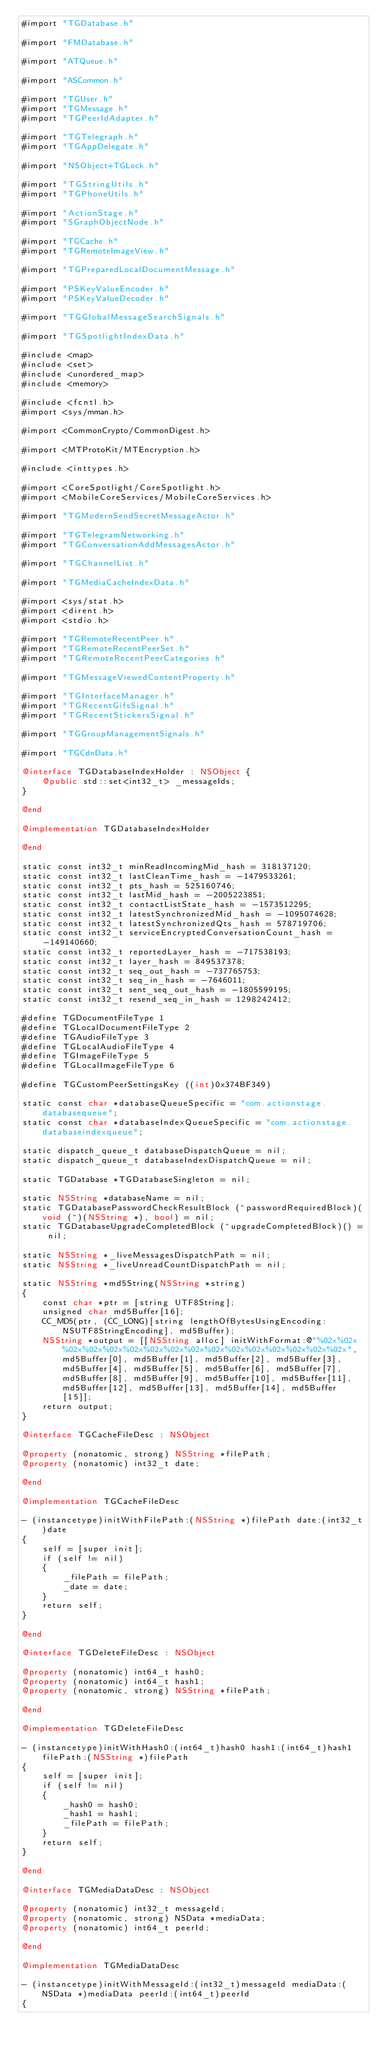<code> <loc_0><loc_0><loc_500><loc_500><_ObjectiveC_>#import "TGDatabase.h"

#import "FMDatabase.h"

#import "ATQueue.h"

#import "ASCommon.h"

#import "TGUser.h"
#import "TGMessage.h"
#import "TGPeerIdAdapter.h"

#import "TGTelegraph.h"
#import "TGAppDelegate.h"

#import "NSObject+TGLock.h"

#import "TGStringUtils.h"
#import "TGPhoneUtils.h"

#import "ActionStage.h"
#import "SGraphObjectNode.h"

#import "TGCache.h"
#import "TGRemoteImageView.h"

#import "TGPreparedLocalDocumentMessage.h"

#import "PSKeyValueEncoder.h"
#import "PSKeyValueDecoder.h"

#import "TGGlobalMessageSearchSignals.h"

#import "TGSpotlightIndexData.h"

#include <map>
#include <set>
#include <unordered_map>
#include <memory>

#include <fcntl.h>
#import <sys/mman.h>

#import <CommonCrypto/CommonDigest.h>

#import <MTProtoKit/MTEncryption.h>

#include <inttypes.h>

#import <CoreSpotlight/CoreSpotlight.h>
#import <MobileCoreServices/MobileCoreServices.h>

#import "TGModernSendSecretMessageActor.h"

#import "TGTelegramNetworking.h"
#import "TGConversationAddMessagesActor.h"

#import "TGChannelList.h"

#import "TGMediaCacheIndexData.h"

#import <sys/stat.h>
#import <dirent.h>
#import <stdio.h>

#import "TGRemoteRecentPeer.h"
#import "TGRemoteRecentPeerSet.h"
#import "TGRemoteRecentPeerCategories.h"

#import "TGMessageViewedContentProperty.h"

#import "TGInterfaceManager.h"
#import "TGRecentGifsSignal.h"
#import "TGRecentStickersSignal.h"

#import "TGGroupManagementSignals.h"

#import "TGCdnData.h"

@interface TGDatabaseIndexHolder : NSObject {
    @public std::set<int32_t> _messageIds;
}

@end

@implementation TGDatabaseIndexHolder

@end

static const int32_t minReadIncomingMid_hash = 318137120;
static const int32_t lastCleanTime_hash = -1479533261;
static const int32_t pts_hash = 525160746;
static const int32_t lastMid_hash = -2005223851;
static const int32_t contactListState_hash = -1573512295;
static const int32_t latestSynchronizedMid_hash = -1095074628;
static const int32_t latestSynchronizedQts_hash = 578719706;
static const int32_t serviceEncryptedConversationCount_hash = -149140660;
static const int32_t reportedLayer_hash = -717538193;
static const int32_t layer_hash = 849537378;
static const int32_t seq_out_hash = -737765753;
static const int32_t seq_in_hash = -7646011;
static const int32_t sent_seq_out_hash = -1805599195;
static const int32_t resend_seq_in_hash = 1298242412;

#define TGDocumentFileType 1
#define TGLocalDocumentFileType 2
#define TGAudioFileType 3
#define TGLocalAudioFileType 4
#define TGImageFileType 5
#define TGLocalImageFileType 6

#define TGCustomPeerSettingsKey ((int)0x374BF349)

static const char *databaseQueueSpecific = "com.actionstage.databasequeue";
static const char *databaseIndexQueueSpecific = "com.actionstage.databaseindexqueue";

static dispatch_queue_t databaseDispatchQueue = nil;
static dispatch_queue_t databaseIndexDispatchQueue = nil;

static TGDatabase *TGDatabaseSingleton = nil;

static NSString *databaseName = nil;
static TGDatabasePasswordCheckResultBlock (^passwordRequiredBlock)(void (^)(NSString *), bool) = nil;
static TGDatabaseUpgradeCompletedBlock (^upgradeCompletedBlock)() = nil;

static NSString *_liveMessagesDispatchPath = nil;
static NSString *_liveUnreadCountDispatchPath = nil;

static NSString *md5String(NSString *string)
{
    const char *ptr = [string UTF8String];
    unsigned char md5Buffer[16];
    CC_MD5(ptr, (CC_LONG)[string lengthOfBytesUsingEncoding:NSUTF8StringEncoding], md5Buffer);
    NSString *output = [[NSString alloc] initWithFormat:@"%02x%02x%02x%02x%02x%02x%02x%02x%02x%02x%02x%02x%02x%02x%02x%02x", md5Buffer[0], md5Buffer[1], md5Buffer[2], md5Buffer[3], md5Buffer[4], md5Buffer[5], md5Buffer[6], md5Buffer[7], md5Buffer[8], md5Buffer[9], md5Buffer[10], md5Buffer[11], md5Buffer[12], md5Buffer[13], md5Buffer[14], md5Buffer[15]];
    return output;
}

@interface TGCacheFileDesc : NSObject

@property (nonatomic, strong) NSString *filePath;
@property (nonatomic) int32_t date;

@end

@implementation TGCacheFileDesc

- (instancetype)initWithFilePath:(NSString *)filePath date:(int32_t)date
{
    self = [super init];
    if (self != nil)
    {
        _filePath = filePath;
        _date = date;
    }
    return self;
}

@end

@interface TGDeleteFileDesc : NSObject

@property (nonatomic) int64_t hash0;
@property (nonatomic) int64_t hash1;
@property (nonatomic, strong) NSString *filePath;

@end

@implementation TGDeleteFileDesc

- (instancetype)initWithHash0:(int64_t)hash0 hash1:(int64_t)hash1 filePath:(NSString *)filePath
{
    self = [super init];
    if (self != nil)
    {
        _hash0 = hash0;
        _hash1 = hash1;
        _filePath = filePath;
    }
    return self;
}

@end

@interface TGMediaDataDesc : NSObject

@property (nonatomic) int32_t messageId;
@property (nonatomic, strong) NSData *mediaData;
@property (nonatomic) int64_t peerId;

@end

@implementation TGMediaDataDesc

- (instancetype)initWithMessageId:(int32_t)messageId mediaData:(NSData *)mediaData peerId:(int64_t)peerId
{</code> 